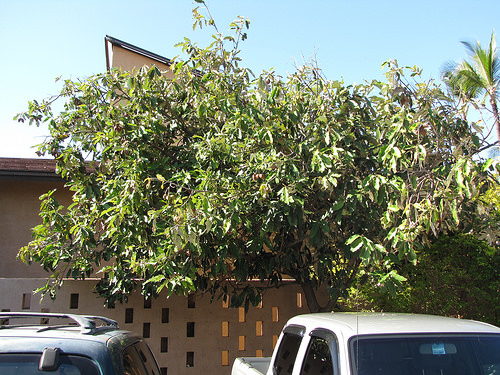<image>
Is the tree behind the car? Yes. From this viewpoint, the tree is positioned behind the car, with the car partially or fully occluding the tree. 